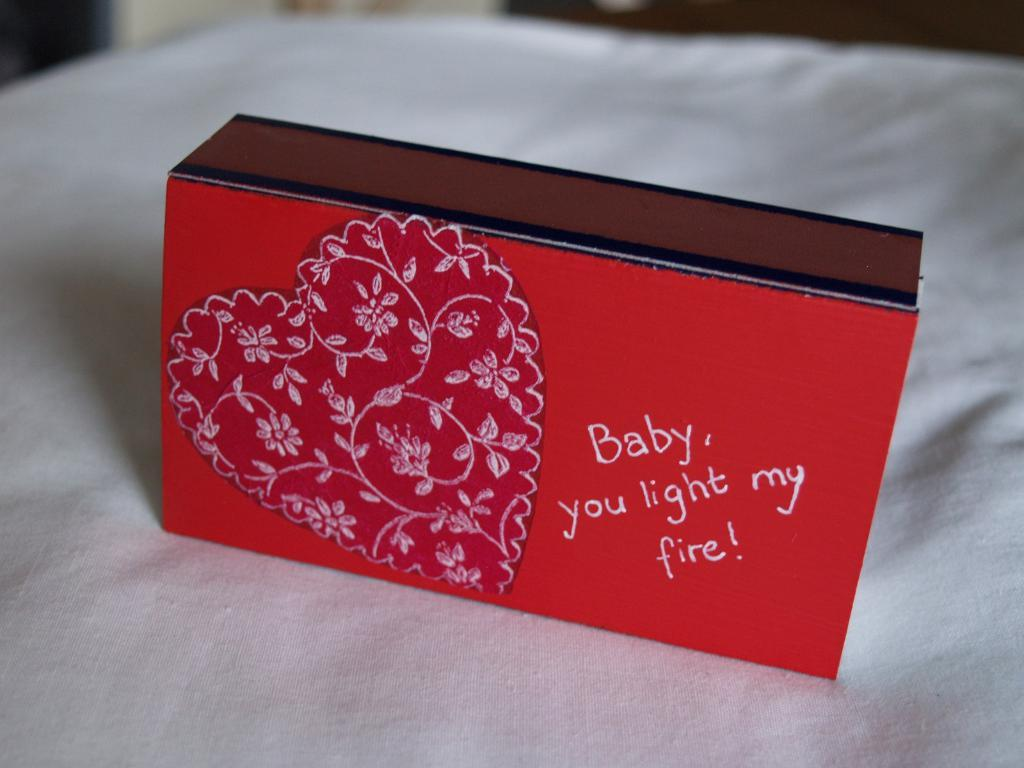<image>
Share a concise interpretation of the image provided. A red box shows a heart and reads Baby, you light my fire! 